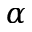Convert formula to latex. <formula><loc_0><loc_0><loc_500><loc_500>\alpha</formula> 